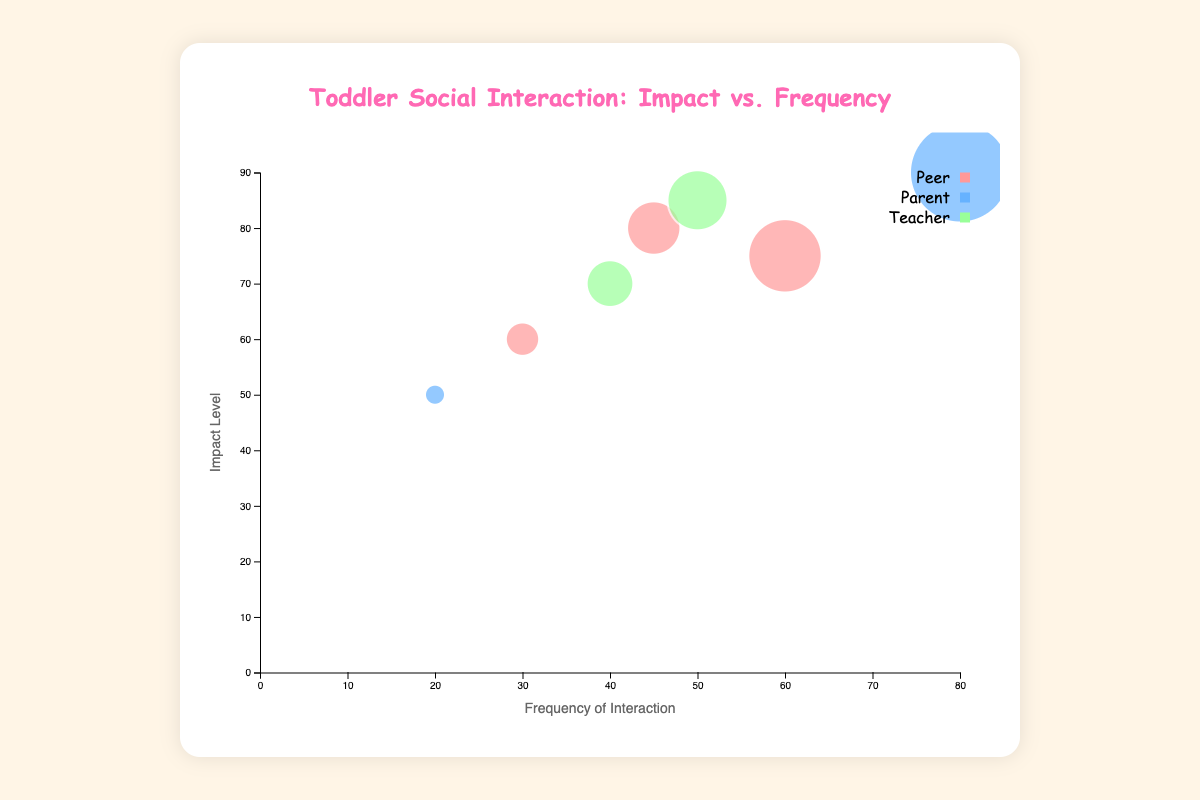What is the title of the chart? The title of the chart is displayed at the top within the chart container. It describes the overall subject of the chart.
Answer: Toddler Social Interaction: Impact vs. Frequency What does the x-axis represent? The x-axis is labeled "Frequency of Interaction" and it measures how often different types of social interactions occur.
Answer: Frequency of Interaction Which social interaction type has the highest impact level? By checking the highest point on the y-axis among all the bubbles, the "parent" interaction at home has the highest impact level.
Answer: parent In which context does the peer interaction have the highest frequency? Compare the frequencies of all peer interactions; peer interaction at the playground has the highest frequency.
Answer: playground What is the size range of the bubbles? The size of the bubbles represents the frequency of interactions. The smallest frequency is 20 and the largest is 80, so the size scales accordingly between these values.
Answer: 10 to 50 How does the impact level of peer interactions at daycare compare to those at the playground? Compare the y-values of peer interactions at daycare (80) and playground (75).
Answer: Higher What is the total frequency of interactions involving teachers? Sum the frequencies of interactions involving teachers: 50 (daycare) + 40 (pre-nursery school) = 90.
Answer: 90 Which interaction has the lowest impact level and what is its context? Find the bubble with the lowest y-value, which corresponds to the parent interaction at the grocery store.
Answer: grocery store What is the color assigned to parent interactions on the chart? By observing the color of bubbles representing parent interactions, which is consistent across the chart, it is blue.
Answer: Blue How do the frequencies of parent interactions compare to peer interactions in all contexts? Sum the frequencies of parent interactions (home: 80; grocery store: 20) and peer interactions (playground: 60; daycare: 45; park: 30). Compare the totals: Parent = 100, Peer = 135.
Answer: Less than 